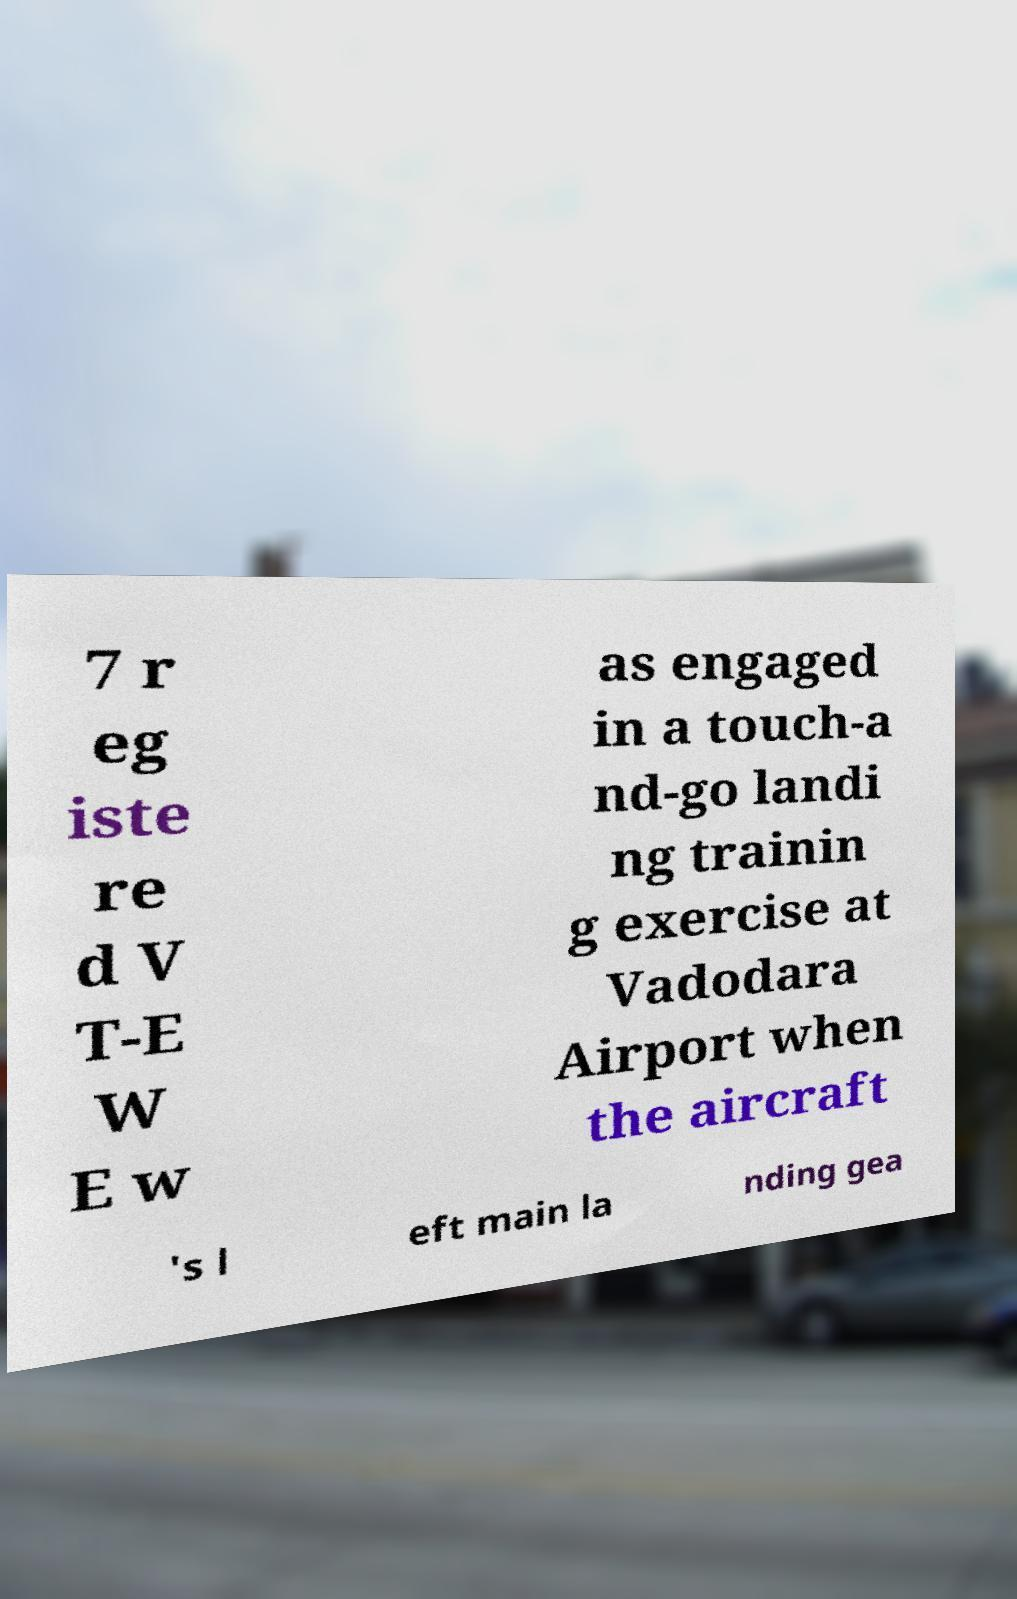There's text embedded in this image that I need extracted. Can you transcribe it verbatim? 7 r eg iste re d V T-E W E w as engaged in a touch-a nd-go landi ng trainin g exercise at Vadodara Airport when the aircraft 's l eft main la nding gea 